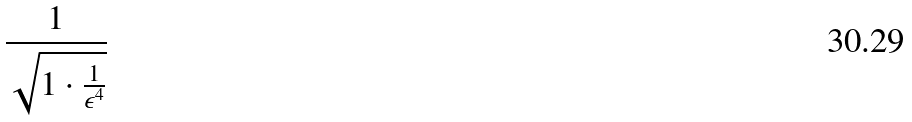<formula> <loc_0><loc_0><loc_500><loc_500>\frac { 1 } { \sqrt { 1 \cdot \frac { 1 } { \epsilon ^ { 4 } } } }</formula> 